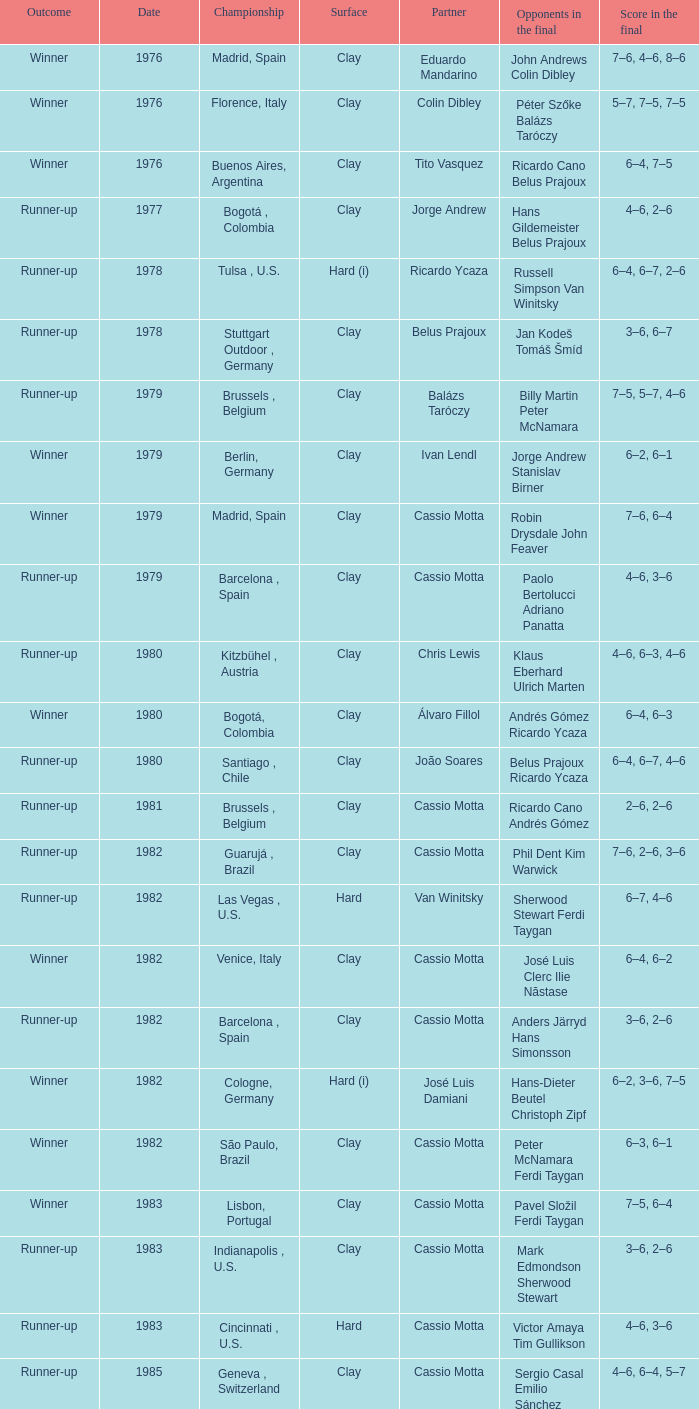What is the result on a rigid surface, when the score in the finale was 4-6, 3-6? Runner-up. 